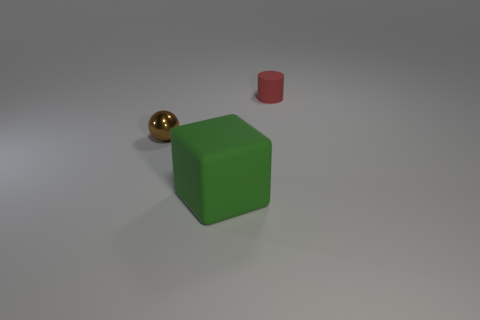The object that is the same material as the big cube is what size?
Give a very brief answer. Small. There is a thing that is in front of the tiny brown ball; how many objects are to the left of it?
Give a very brief answer. 1. Are the object that is right of the big matte block and the big cube made of the same material?
Your answer should be compact. Yes. Is there anything else that is made of the same material as the small brown object?
Offer a terse response. No. What is the size of the matte object that is behind the tiny object in front of the small red matte thing?
Your answer should be compact. Small. What size is the rubber object in front of the small thing that is right of the matte thing that is in front of the brown thing?
Your answer should be compact. Large. Does the matte thing on the right side of the green cube have the same shape as the tiny thing that is in front of the red matte object?
Your response must be concise. No. How many other things are the same color as the cylinder?
Offer a terse response. 0. Do the rubber object to the left of the red cylinder and the ball have the same size?
Ensure brevity in your answer.  No. Do the tiny thing that is to the left of the tiny matte cylinder and the object on the right side of the large green cube have the same material?
Ensure brevity in your answer.  No. 